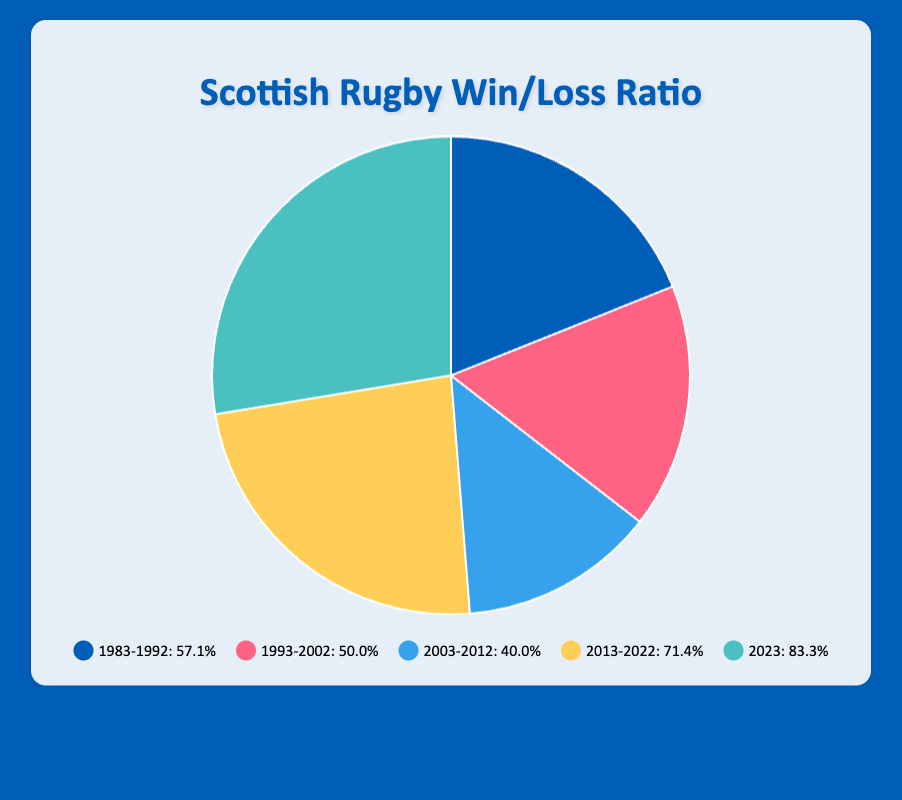What period had the highest win ratio? By looking at the pie chart, identify the segment with the greatest proportion of wins relative to total games played. This can be done by comparing the size of the segments visually. The period 2013-2022 appears to have the largest segment.
Answer: 2013-2022 Which period had an equal number of wins and losses? Refer to the pie chart and look for a segment labeled with a period where the win ratio is 50%, meaning the number of wins and losses are equal. The chart shows this for the period 1993-2002.
Answer: 1993-2002 By how much did the win ratio increase from the period 2003-2012 to 2013-2022? First, identify the win ratios for 2003-2012 and 2013-2022 from the pie chart. 2003-2012 has 30 wins and 45 losses (40% win ratio), and 2013-2022 has 50 wins and 20 losses (71.4% win ratio). Subtract 40% from 71.4% to find the increase.
Answer: 31.4% Which period had the smallest number of games played? Look at the segments representing different periods in the pie chart and add up wins and losses for each period. The period with the smallest combined total of wins and losses represents the fewest games played. The period 2023 has the smallest total (5 wins + 1 loss = 6 games).
Answer: 2023 How many total wins were there from 2013 to 2023? Sum up the number of wins from the periods 2013-2022 and 2023. According to the data, 2013-2022 has 50 wins and 2023 has 5 wins. Adding these together results in a total of 55 wins.
Answer: 55 Which period had a lower win ratio, 1983-1992 or 2003-2012? Identify the win ratios for the periods 1983-1992 and 2003-2012 from the pie chart. Divide the wins by the total games played for each period. 1983-1992 has 40 wins and 30 losses (57.1% win ratio), and 2003-2012 has 30 wins and 45 losses (40% win ratio). Comparing the two, 2003-2012 has the lower win ratio.
Answer: 2003-2012 What was the total of wins and losses over the entire four-decade period (1983-2023)? Add up all the wins and losses from each period as shown in the pie chart: 
1983-1992 has 40 wins and 30 losses (70 games), 
1993-2002 has 35 wins and 35 losses (70 games),
2003-2012 has 30 wins and 45 losses (75 games),
2013-2022 has 50 wins and 20 losses (70 games),
2023 has 5 wins and 1 loss (6 games). 
Summing these together gives 70+70+75+70+6 = 291 games.
Answer: 291 